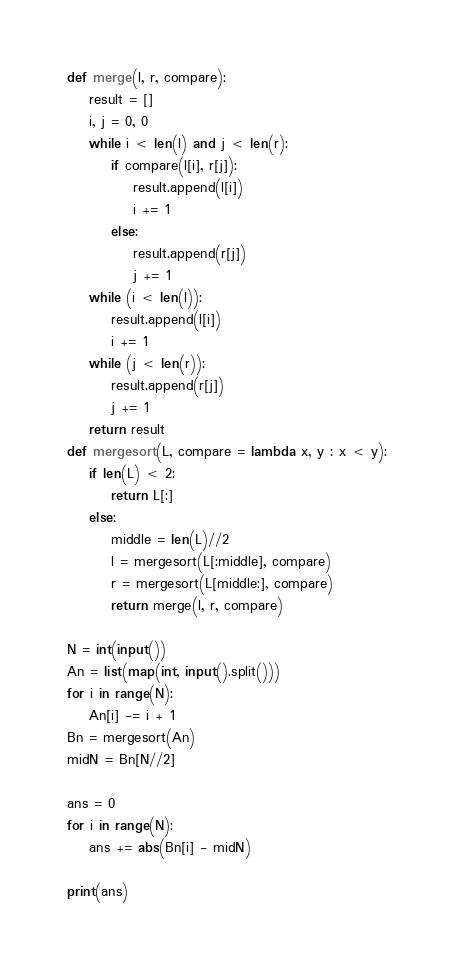<code> <loc_0><loc_0><loc_500><loc_500><_Python_>def merge(l, r, compare):
    result = []
    i, j = 0, 0
    while i < len(l) and j < len(r):
        if compare(l[i], r[j]):
            result.append(l[i])
            i += 1
        else:
            result.append(r[j])
            j += 1
    while (i < len(l)):
        result.append(l[i])
        i += 1
    while (j < len(r)):
        result.append(r[j])
        j += 1
    return result
def mergesort(L, compare = lambda x, y : x < y):
    if len(L) < 2:
        return L[:]
    else:
        middle = len(L)//2
        l = mergesort(L[:middle], compare)
        r = mergesort(L[middle:], compare)
        return merge(l, r, compare)

N = int(input())
An = list(map(int, input().split()))
for i in range(N):
    An[i] -= i + 1
Bn = mergesort(An)
midN = Bn[N//2]

ans = 0
for i in range(N):
    ans += abs(Bn[i] - midN)

print(ans)
</code> 